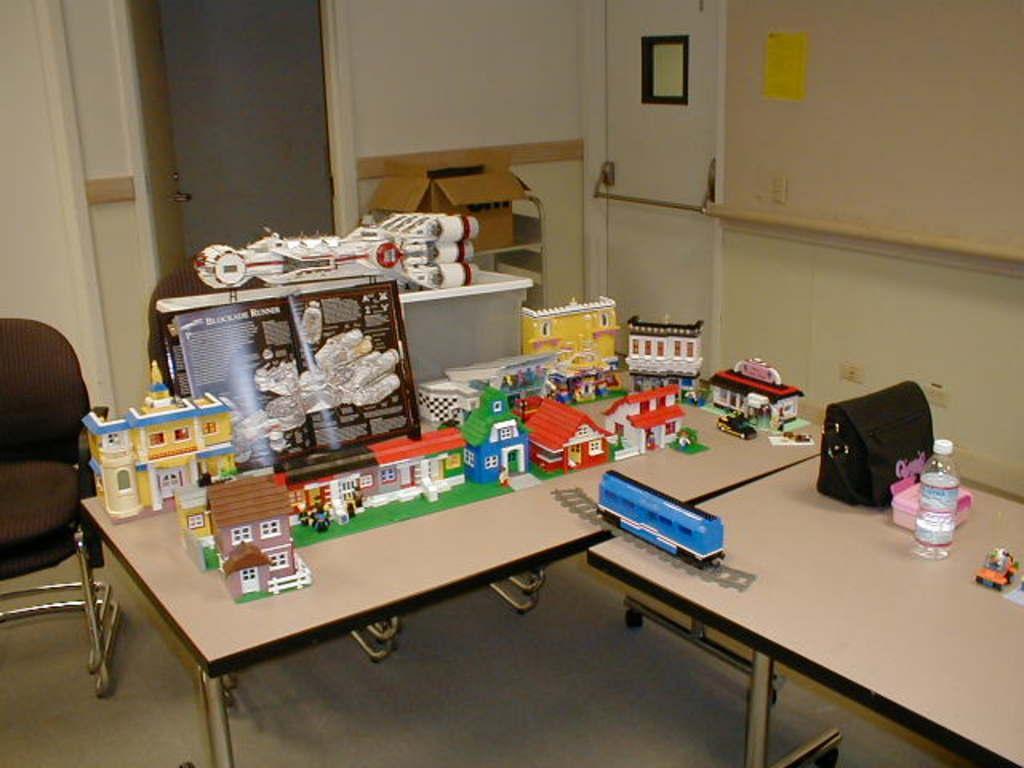Could you give a brief overview of what you see in this image? There are some toys on a table. There is chair beside the table. There are two doors in the background. 